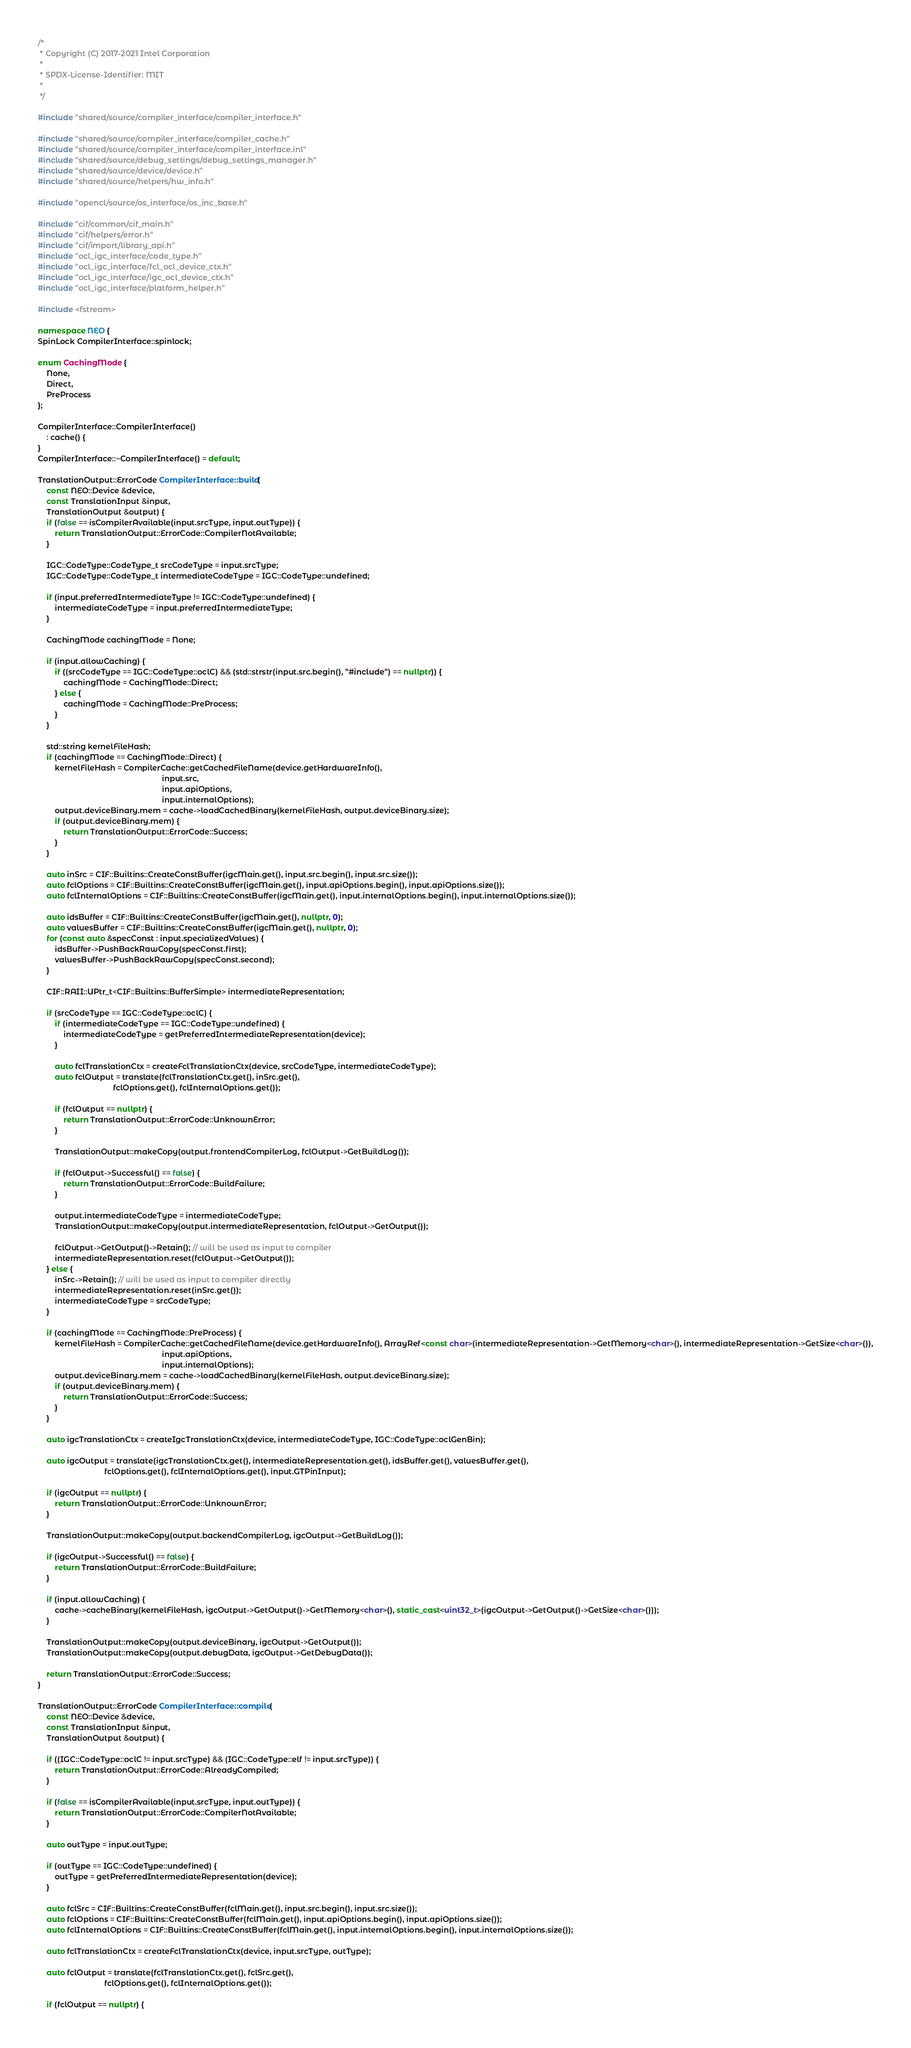<code> <loc_0><loc_0><loc_500><loc_500><_C++_>/*
 * Copyright (C) 2017-2021 Intel Corporation
 *
 * SPDX-License-Identifier: MIT
 *
 */

#include "shared/source/compiler_interface/compiler_interface.h"

#include "shared/source/compiler_interface/compiler_cache.h"
#include "shared/source/compiler_interface/compiler_interface.inl"
#include "shared/source/debug_settings/debug_settings_manager.h"
#include "shared/source/device/device.h"
#include "shared/source/helpers/hw_info.h"

#include "opencl/source/os_interface/os_inc_base.h"

#include "cif/common/cif_main.h"
#include "cif/helpers/error.h"
#include "cif/import/library_api.h"
#include "ocl_igc_interface/code_type.h"
#include "ocl_igc_interface/fcl_ocl_device_ctx.h"
#include "ocl_igc_interface/igc_ocl_device_ctx.h"
#include "ocl_igc_interface/platform_helper.h"

#include <fstream>

namespace NEO {
SpinLock CompilerInterface::spinlock;

enum CachingMode {
    None,
    Direct,
    PreProcess
};

CompilerInterface::CompilerInterface()
    : cache() {
}
CompilerInterface::~CompilerInterface() = default;

TranslationOutput::ErrorCode CompilerInterface::build(
    const NEO::Device &device,
    const TranslationInput &input,
    TranslationOutput &output) {
    if (false == isCompilerAvailable(input.srcType, input.outType)) {
        return TranslationOutput::ErrorCode::CompilerNotAvailable;
    }

    IGC::CodeType::CodeType_t srcCodeType = input.srcType;
    IGC::CodeType::CodeType_t intermediateCodeType = IGC::CodeType::undefined;

    if (input.preferredIntermediateType != IGC::CodeType::undefined) {
        intermediateCodeType = input.preferredIntermediateType;
    }

    CachingMode cachingMode = None;

    if (input.allowCaching) {
        if ((srcCodeType == IGC::CodeType::oclC) && (std::strstr(input.src.begin(), "#include") == nullptr)) {
            cachingMode = CachingMode::Direct;
        } else {
            cachingMode = CachingMode::PreProcess;
        }
    }

    std::string kernelFileHash;
    if (cachingMode == CachingMode::Direct) {
        kernelFileHash = CompilerCache::getCachedFileName(device.getHardwareInfo(),
                                                          input.src,
                                                          input.apiOptions,
                                                          input.internalOptions);
        output.deviceBinary.mem = cache->loadCachedBinary(kernelFileHash, output.deviceBinary.size);
        if (output.deviceBinary.mem) {
            return TranslationOutput::ErrorCode::Success;
        }
    }

    auto inSrc = CIF::Builtins::CreateConstBuffer(igcMain.get(), input.src.begin(), input.src.size());
    auto fclOptions = CIF::Builtins::CreateConstBuffer(igcMain.get(), input.apiOptions.begin(), input.apiOptions.size());
    auto fclInternalOptions = CIF::Builtins::CreateConstBuffer(igcMain.get(), input.internalOptions.begin(), input.internalOptions.size());

    auto idsBuffer = CIF::Builtins::CreateConstBuffer(igcMain.get(), nullptr, 0);
    auto valuesBuffer = CIF::Builtins::CreateConstBuffer(igcMain.get(), nullptr, 0);
    for (const auto &specConst : input.specializedValues) {
        idsBuffer->PushBackRawCopy(specConst.first);
        valuesBuffer->PushBackRawCopy(specConst.second);
    }

    CIF::RAII::UPtr_t<CIF::Builtins::BufferSimple> intermediateRepresentation;

    if (srcCodeType == IGC::CodeType::oclC) {
        if (intermediateCodeType == IGC::CodeType::undefined) {
            intermediateCodeType = getPreferredIntermediateRepresentation(device);
        }

        auto fclTranslationCtx = createFclTranslationCtx(device, srcCodeType, intermediateCodeType);
        auto fclOutput = translate(fclTranslationCtx.get(), inSrc.get(),
                                   fclOptions.get(), fclInternalOptions.get());

        if (fclOutput == nullptr) {
            return TranslationOutput::ErrorCode::UnknownError;
        }

        TranslationOutput::makeCopy(output.frontendCompilerLog, fclOutput->GetBuildLog());

        if (fclOutput->Successful() == false) {
            return TranslationOutput::ErrorCode::BuildFailure;
        }

        output.intermediateCodeType = intermediateCodeType;
        TranslationOutput::makeCopy(output.intermediateRepresentation, fclOutput->GetOutput());

        fclOutput->GetOutput()->Retain(); // will be used as input to compiler
        intermediateRepresentation.reset(fclOutput->GetOutput());
    } else {
        inSrc->Retain(); // will be used as input to compiler directly
        intermediateRepresentation.reset(inSrc.get());
        intermediateCodeType = srcCodeType;
    }

    if (cachingMode == CachingMode::PreProcess) {
        kernelFileHash = CompilerCache::getCachedFileName(device.getHardwareInfo(), ArrayRef<const char>(intermediateRepresentation->GetMemory<char>(), intermediateRepresentation->GetSize<char>()),
                                                          input.apiOptions,
                                                          input.internalOptions);
        output.deviceBinary.mem = cache->loadCachedBinary(kernelFileHash, output.deviceBinary.size);
        if (output.deviceBinary.mem) {
            return TranslationOutput::ErrorCode::Success;
        }
    }

    auto igcTranslationCtx = createIgcTranslationCtx(device, intermediateCodeType, IGC::CodeType::oclGenBin);

    auto igcOutput = translate(igcTranslationCtx.get(), intermediateRepresentation.get(), idsBuffer.get(), valuesBuffer.get(),
                               fclOptions.get(), fclInternalOptions.get(), input.GTPinInput);

    if (igcOutput == nullptr) {
        return TranslationOutput::ErrorCode::UnknownError;
    }

    TranslationOutput::makeCopy(output.backendCompilerLog, igcOutput->GetBuildLog());

    if (igcOutput->Successful() == false) {
        return TranslationOutput::ErrorCode::BuildFailure;
    }

    if (input.allowCaching) {
        cache->cacheBinary(kernelFileHash, igcOutput->GetOutput()->GetMemory<char>(), static_cast<uint32_t>(igcOutput->GetOutput()->GetSize<char>()));
    }

    TranslationOutput::makeCopy(output.deviceBinary, igcOutput->GetOutput());
    TranslationOutput::makeCopy(output.debugData, igcOutput->GetDebugData());

    return TranslationOutput::ErrorCode::Success;
}

TranslationOutput::ErrorCode CompilerInterface::compile(
    const NEO::Device &device,
    const TranslationInput &input,
    TranslationOutput &output) {

    if ((IGC::CodeType::oclC != input.srcType) && (IGC::CodeType::elf != input.srcType)) {
        return TranslationOutput::ErrorCode::AlreadyCompiled;
    }

    if (false == isCompilerAvailable(input.srcType, input.outType)) {
        return TranslationOutput::ErrorCode::CompilerNotAvailable;
    }

    auto outType = input.outType;

    if (outType == IGC::CodeType::undefined) {
        outType = getPreferredIntermediateRepresentation(device);
    }

    auto fclSrc = CIF::Builtins::CreateConstBuffer(fclMain.get(), input.src.begin(), input.src.size());
    auto fclOptions = CIF::Builtins::CreateConstBuffer(fclMain.get(), input.apiOptions.begin(), input.apiOptions.size());
    auto fclInternalOptions = CIF::Builtins::CreateConstBuffer(fclMain.get(), input.internalOptions.begin(), input.internalOptions.size());

    auto fclTranslationCtx = createFclTranslationCtx(device, input.srcType, outType);

    auto fclOutput = translate(fclTranslationCtx.get(), fclSrc.get(),
                               fclOptions.get(), fclInternalOptions.get());

    if (fclOutput == nullptr) {</code> 